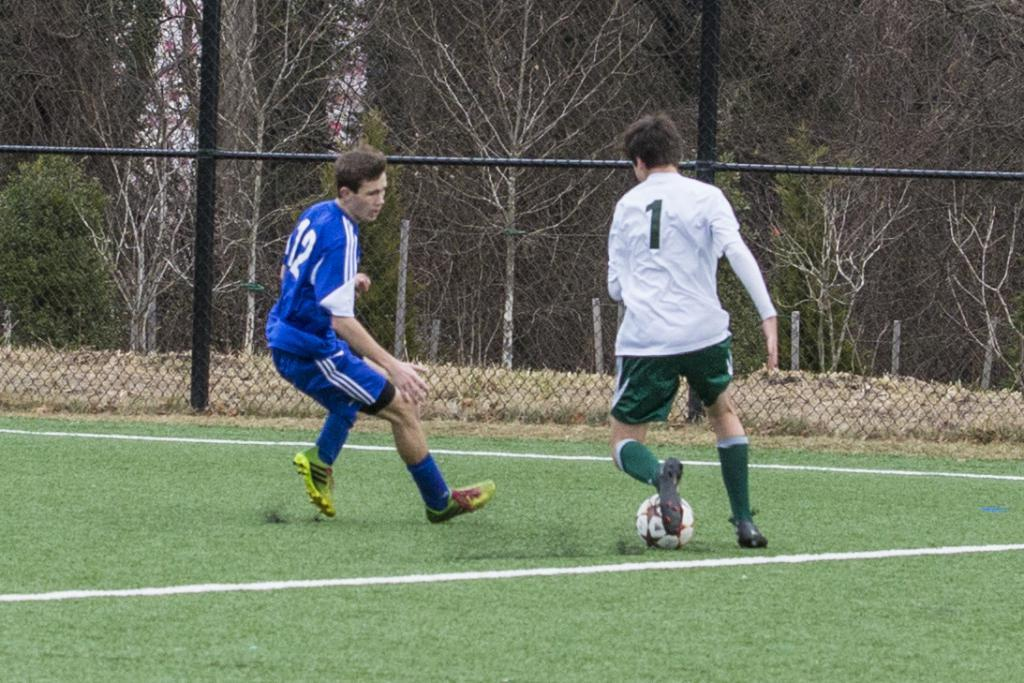<image>
Provide a brief description of the given image. A footballer wearing w white top with the number one on it attempts to get round an opponent wearing blue and the number twelve. 